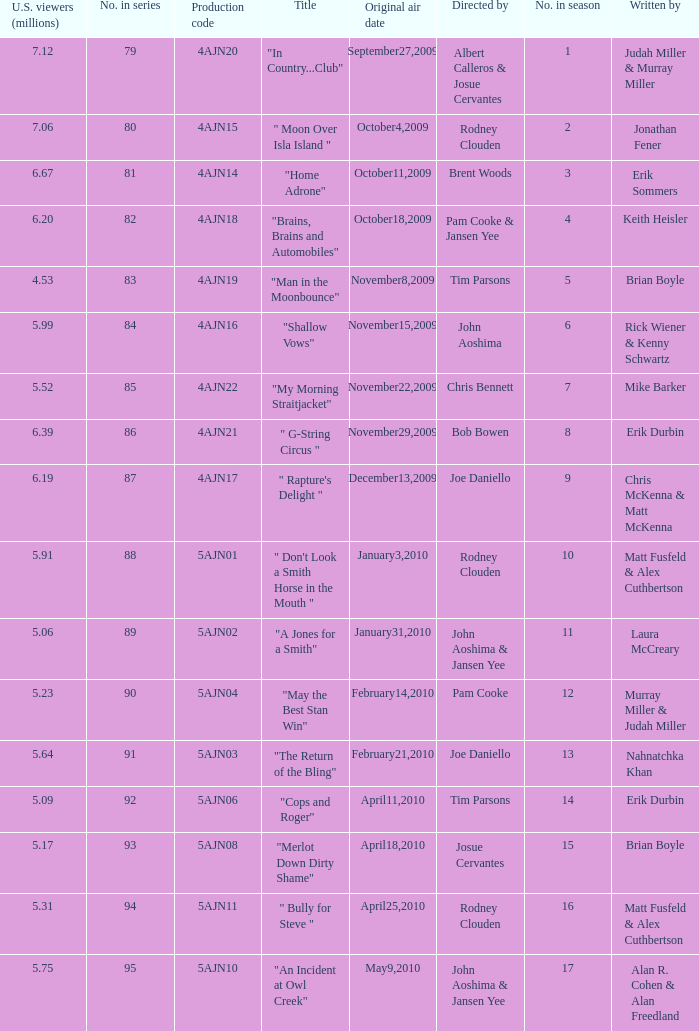Name who wrote 5ajn11 Matt Fusfeld & Alex Cuthbertson. 